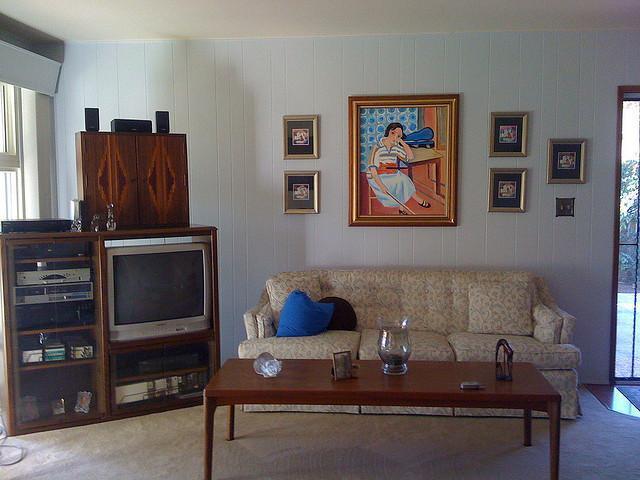How many vases are there?
Give a very brief answer. 1. How many pillows are on the sofa?
Give a very brief answer. 4. How many pictures do you see?
Give a very brief answer. 6. How many mirrors are hanging on the wall?
Give a very brief answer. 0. How many vases are on the table?
Give a very brief answer. 1. How many rooms is this?
Give a very brief answer. 1. 